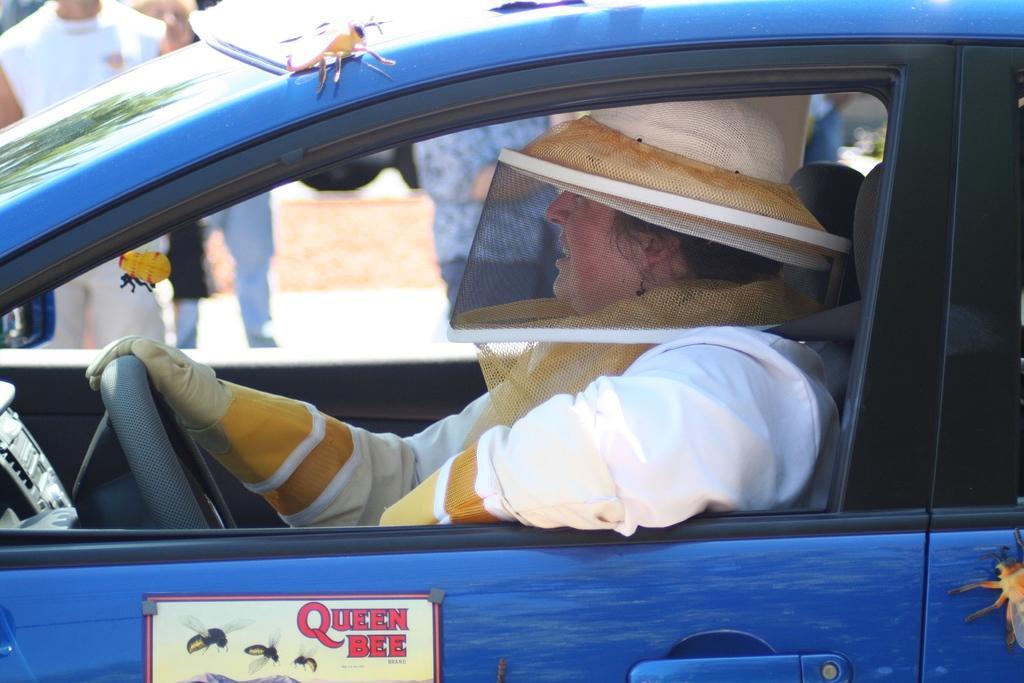Can you describe this image briefly? In this image there is a car and in the car there is one person who is sitting, and he is wearing a hat and on the car there are some objects. And in the background there are some people and walkway. 